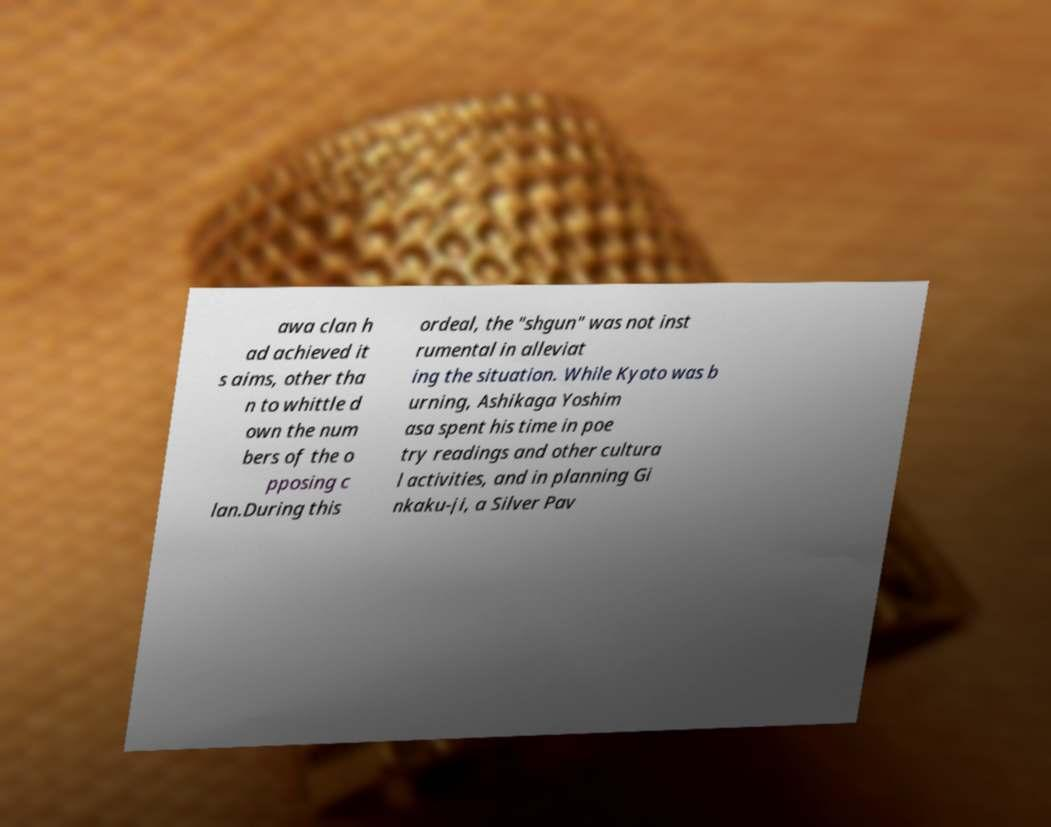For documentation purposes, I need the text within this image transcribed. Could you provide that? awa clan h ad achieved it s aims, other tha n to whittle d own the num bers of the o pposing c lan.During this ordeal, the "shgun" was not inst rumental in alleviat ing the situation. While Kyoto was b urning, Ashikaga Yoshim asa spent his time in poe try readings and other cultura l activities, and in planning Gi nkaku-ji, a Silver Pav 